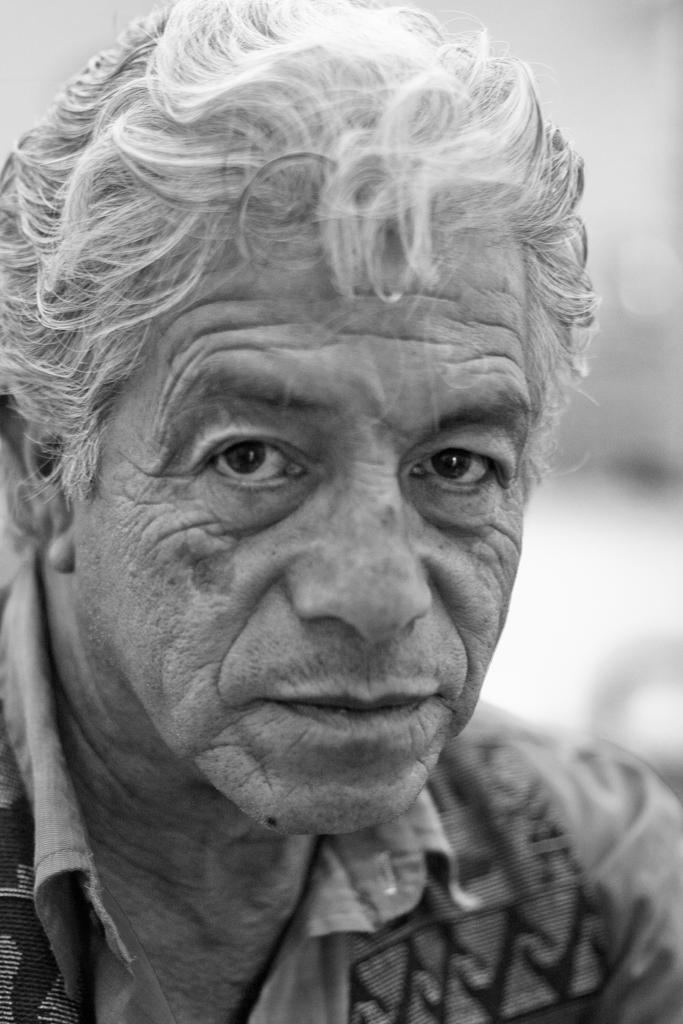What type of picture is in the image? The image contains a black and white picture. What is the subject of the picture? The picture depicts a man. What is the weight of the woman in the image? There is no woman present in the image, only a picture of a man. How does the man say good-bye in the image? The image is black and white and does not depict any action or interaction, so it is impossible to determine how the man says good-bye. 